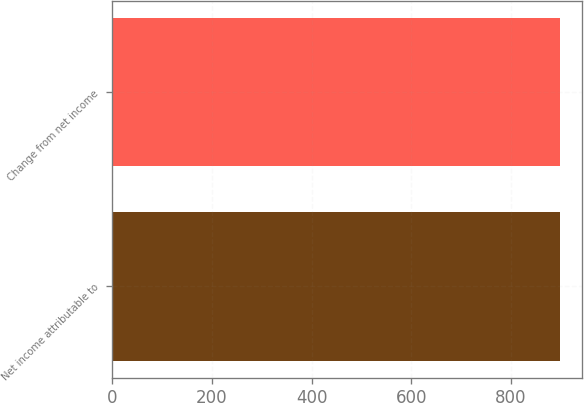<chart> <loc_0><loc_0><loc_500><loc_500><bar_chart><fcel>Net income attributable to<fcel>Change from net income<nl><fcel>898<fcel>898.1<nl></chart> 